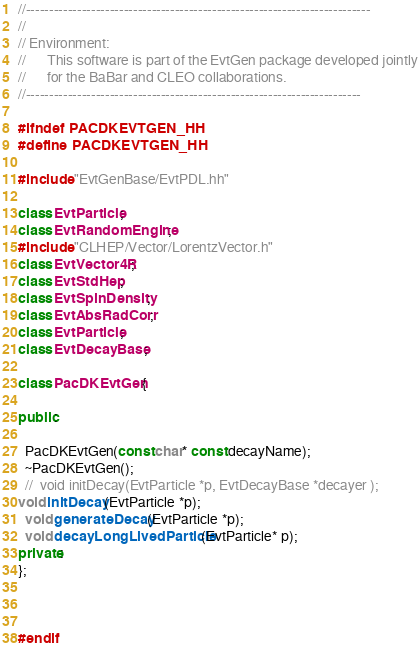Convert code to text. <code><loc_0><loc_0><loc_500><loc_500><_C++_>//--------------------------------------------------------------------------
//
// Environment:
//      This software is part of the EvtGen package developed jointly
//      for the BaBar and CLEO collaborations.  
//------------------------------------------------------------------------

#ifndef PACDKEVTGEN_HH
#define PACDKEVTGEN_HH

#include "EvtGenBase/EvtPDL.hh"

class EvtParticle;
class EvtRandomEngine;
#include "CLHEP/Vector/LorentzVector.h"
class EvtVector4R;
class EvtStdHep;
class EvtSpinDensity;
class EvtAbsRadCorr;
class EvtParticle;
class EvtDecayBase;

class PacDKEvtGen{

public:

  PacDKEvtGen(const char* const decayName);
  ~PacDKEvtGen();
  //  void initDecay(EvtParticle *p, EvtDecayBase *decayer );
void initDecay(EvtParticle *p);
  void generateDecay(EvtParticle *p);
  void decayLongLivedParticle(EvtParticle* p);
private:
};



#endif

</code> 